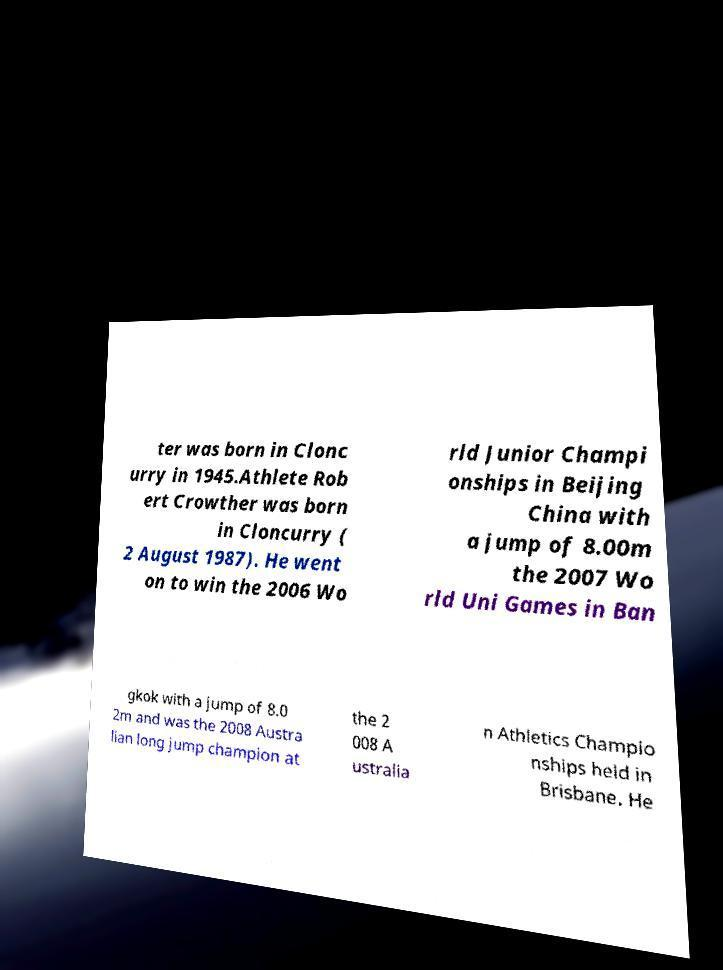Can you read and provide the text displayed in the image?This photo seems to have some interesting text. Can you extract and type it out for me? ter was born in Clonc urry in 1945.Athlete Rob ert Crowther was born in Cloncurry ( 2 August 1987). He went on to win the 2006 Wo rld Junior Champi onships in Beijing China with a jump of 8.00m the 2007 Wo rld Uni Games in Ban gkok with a jump of 8.0 2m and was the 2008 Austra lian long jump champion at the 2 008 A ustralia n Athletics Champio nships held in Brisbane. He 